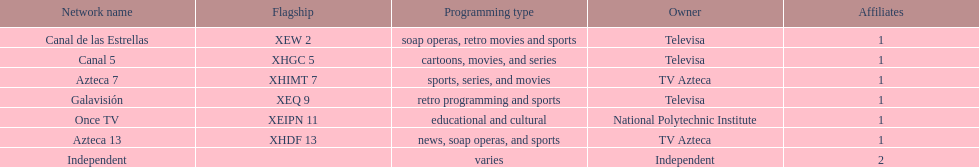Azteca 7 and azteca 13 are both owned by whom? TV Azteca. 